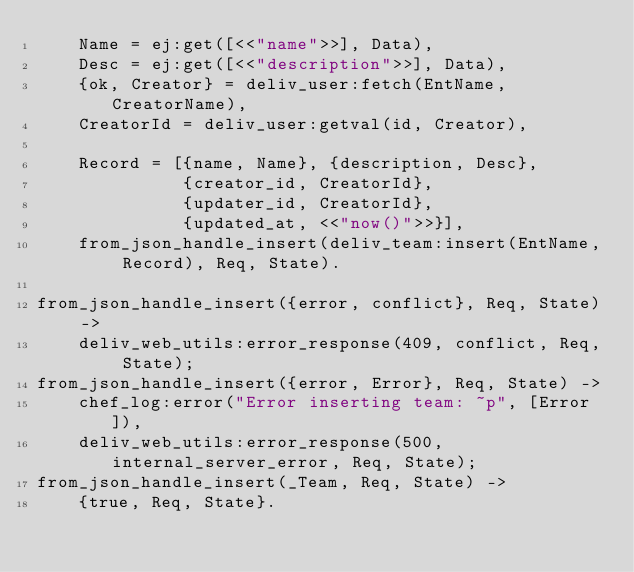<code> <loc_0><loc_0><loc_500><loc_500><_Erlang_>    Name = ej:get([<<"name">>], Data),
    Desc = ej:get([<<"description">>], Data),
    {ok, Creator} = deliv_user:fetch(EntName, CreatorName),
    CreatorId = deliv_user:getval(id, Creator),

    Record = [{name, Name}, {description, Desc},
              {creator_id, CreatorId},
              {updater_id, CreatorId},
              {updated_at, <<"now()">>}],
    from_json_handle_insert(deliv_team:insert(EntName, Record), Req, State).

from_json_handle_insert({error, conflict}, Req, State) ->
    deliv_web_utils:error_response(409, conflict, Req, State);
from_json_handle_insert({error, Error}, Req, State) ->
    chef_log:error("Error inserting team: ~p", [Error]),
    deliv_web_utils:error_response(500, internal_server_error, Req, State);
from_json_handle_insert(_Team, Req, State) ->
    {true, Req, State}.
</code> 